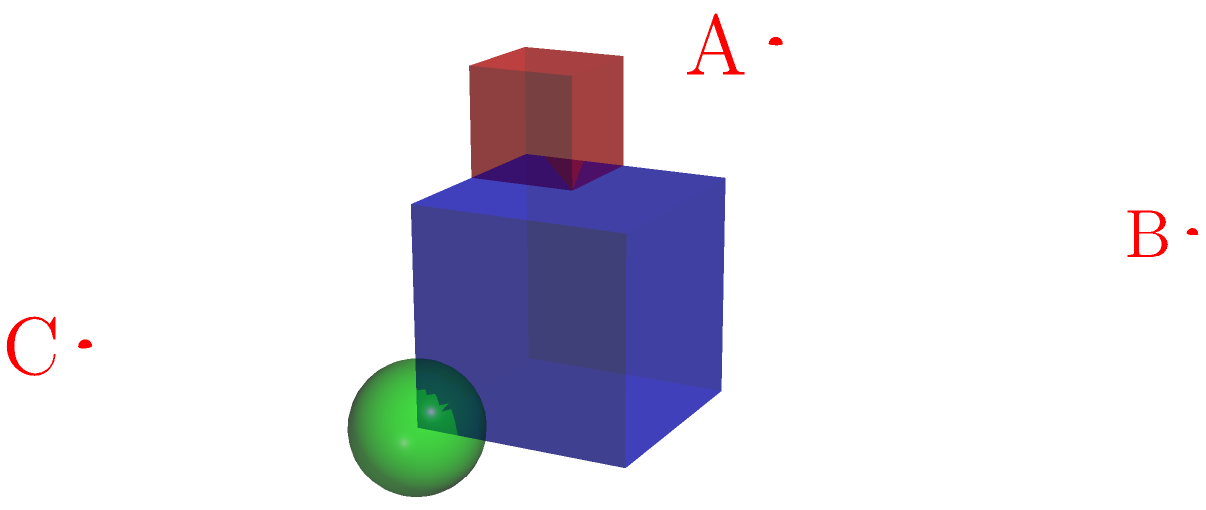In the 3D scene shown above, which camera position (A, B, or C) would provide the best composition and angle to showcase all three objects (blue cube, red cube, and green sphere) effectively? To determine the best camera position, we need to consider several factors:

1. Visibility: All three objects should be clearly visible from the chosen angle.
2. Composition: The arrangement of objects should be balanced and aesthetically pleasing.
3. Depth: The camera angle should convey a sense of depth in the 3D space.
4. Object separation: The objects should not overlap significantly from the chosen viewpoint.

Let's analyze each camera position:

A (2,2,2):
- Provides a three-quarter view, showing multiple faces of the cubes.
- Offers a balanced composition with all objects visible.
- Conveys good depth perception.
- Objects are well-separated in the frame.

B (0,3,1):
- Shows mainly the top faces of the cubes.
- The green sphere might be partially obscured by the blue cube.
- Limited depth perception due to the high angle.
- Objects may appear too close together from this angle.

C (3,0,1):
- Provides a side view of the scene.
- The red cube might be partially hidden behind the blue cube.
- Limited depth perception due to the low angle.
- Objects may overlap significantly from this viewpoint.

Considering these factors, position A (2,2,2) offers the best overall composition and angle. It provides a balanced view of all three objects, showcases the depth of the scene, and ensures that each object is clearly visible and distinguishable.
Answer: A 